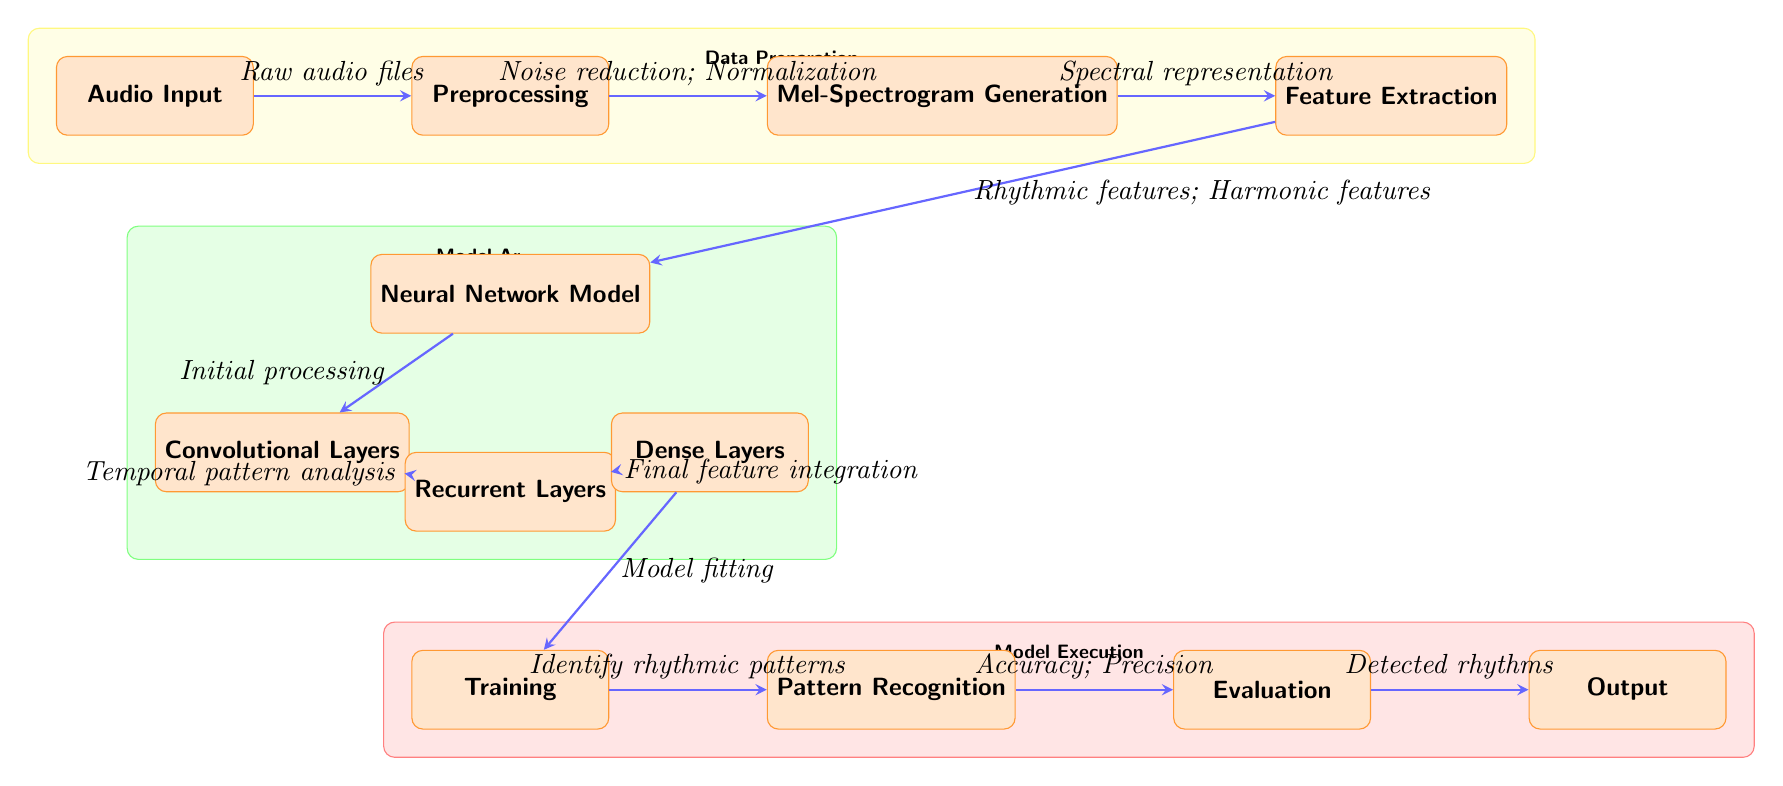What is the first node in the diagram? The first node is labeled "Audio Input," which represents the starting point of the process.
Answer: Audio Input How many boxes are in the "Model Architecture" section? The "Model Architecture" section contains three boxes: "Neural Network Model," "Convolutional Layers," and "Recurrent Layers," plus "Dense Layers."
Answer: Four boxes What does the "Preprocessing" node involve? The "Preprocessing" node involves noise reduction and normalization as indicated in the flow from the "Audio Input" to the "Mel-Spectrogram Generation" nodes.
Answer: Noise reduction; Normalization What process comes after "Feature Extraction"? After "Feature Extraction," the next step is "Neural Network Model," indicating that extracted features are used as input for model training.
Answer: Neural Network Model What is identified in the "Pattern Recognition" stage? The "Pattern Recognition" stage is responsible for identifying rhythmic patterns within the processed data.
Answer: Identify rhythmic patterns Which layers are involved in analyzing temporal patterns? "Recurrent Layers" are specifically mentioned as the process dedicated to temporal pattern analysis within the neural network model.
Answer: Recurrent Layers What feeds into the "Training" node? The "Training" node is fed by data processed through "Neural Network Model," which previously processed features using convolutional and recurrent layers.
Answer: Model fitting How does the "Evaluation" node assess model performance? The "Evaluation" node assesses model performance based on metrics like accuracy and precision that are evaluated after pattern recognition.
Answer: Accuracy; Precision What is the final output of the diagram? The final output of the diagram is labeled "Detected rhythms," which are the rhythms identified from the analysis.
Answer: Detected rhythms 